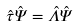Convert formula to latex. <formula><loc_0><loc_0><loc_500><loc_500>\hat { \tau } \hat { \Psi } = \hat { \Lambda } \hat { \Psi }</formula> 